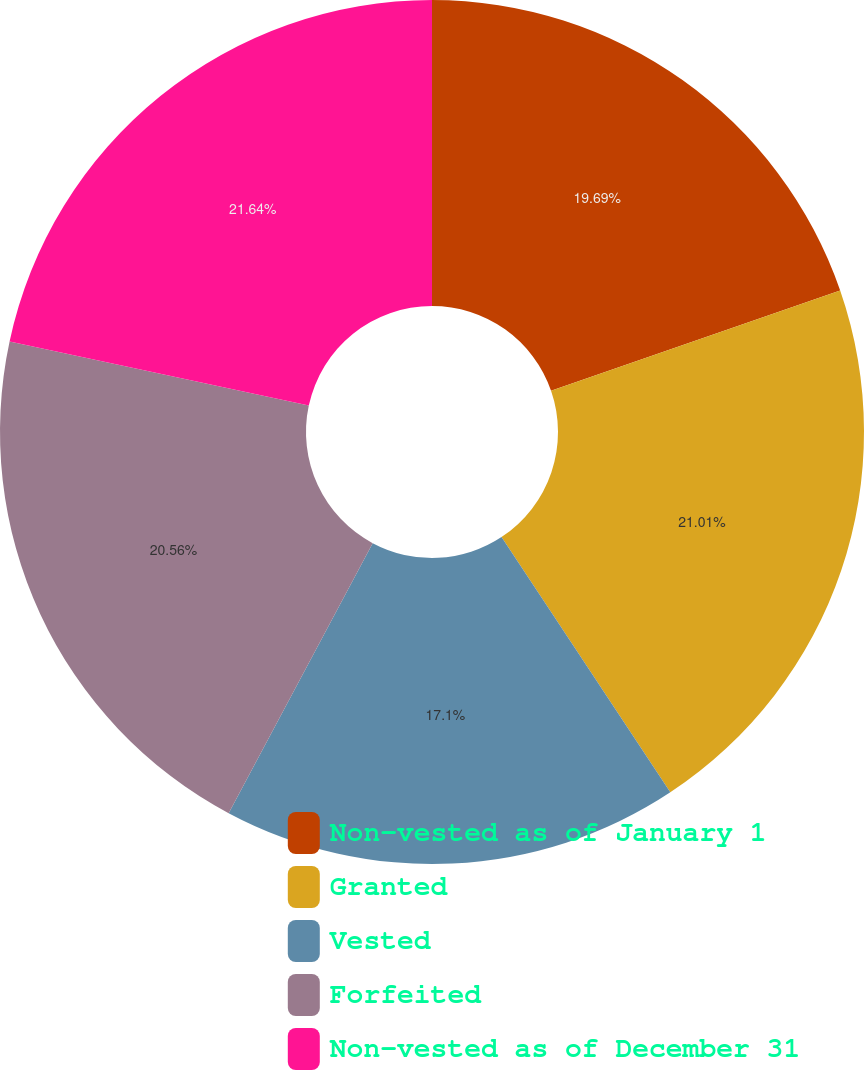Convert chart to OTSL. <chart><loc_0><loc_0><loc_500><loc_500><pie_chart><fcel>Non-vested as of January 1<fcel>Granted<fcel>Vested<fcel>Forfeited<fcel>Non-vested as of December 31<nl><fcel>19.69%<fcel>21.01%<fcel>17.1%<fcel>20.56%<fcel>21.64%<nl></chart> 